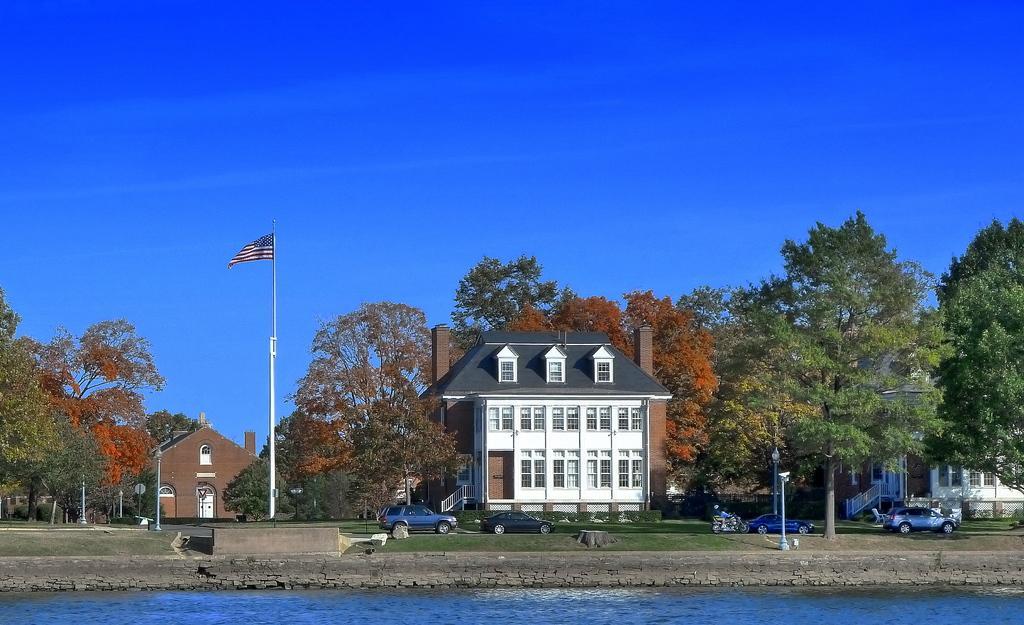Could you give a brief overview of what you see in this image? In this image, there are buildings in between trees. There is pole in the middle of the image. There are some cars beside the lake. In the background of the image, there is a sky. 